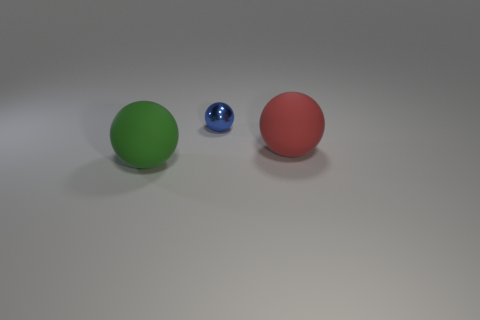Add 1 purple matte cylinders. How many objects exist? 4 Add 1 rubber spheres. How many rubber spheres are left? 3 Add 1 small blocks. How many small blocks exist? 1 Subtract 0 blue blocks. How many objects are left? 3 Subtract all tiny metallic spheres. Subtract all gray objects. How many objects are left? 2 